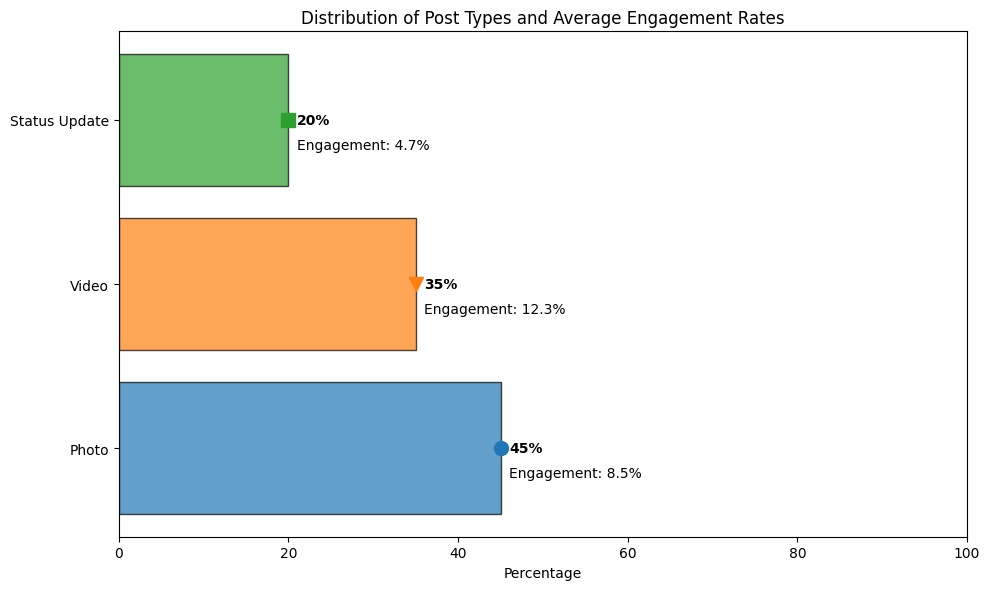What percentage of posts are videos? The chart shows a horizontal bar for videos with a percentage value next to it. This value is 35%.
Answer: 35% Which type of post has the highest average engagement rate? Looking at the bars and their corresponding text annotations, videos have the highest average engagement rate of 12.3%.
Answer: Video Compare the percentage of photo posts to status updates. Photos have a percentage of 45%, while status updates have a percentage of 20%. 45% is greater than 20%.
Answer: Photos have a higher percentage What is the combined percentage of photos and status updates? The percentage of photos is 45%, and the percentage of status updates is 20%. Adding these two percentages gives 45% + 20% = 65%.
Answer: 65% Which post type has both the lowest percentage and the lowest average engagement rate? Status updates have the lowest percentage of 20% and the lowest average engagement rate of 4.7%.
Answer: Status updates Explain the difference in average engagement rates between photos and videos. The average engagement rate for photos is 8.5%, and for videos, it is 12.3%. To find the difference, subtract 8.5% from 12.3%, resulting in 3.8%.
Answer: 3.8% What is the color of the bar for status updates? Looking at the chart, the bar for status updates is green.
Answer: Green How does the average engagement rate of photos compare to status updates? The average engagement rate for photos is 8.5%, while for status updates, it is 4.7%. 8.5% is higher than 4.7%.
Answer: Photos have a higher average engagement rate Which post type has the largest visual representation in the chart? The largest bar on the chart represents photo posts with a percentage of 45%.
Answer: Photos What is the total percentage accounted for by all post types? Summing the percentages of photos (45%), videos (35%), and status updates (20%) results in 45% + 35% + 20% = 100%.
Answer: 100% 